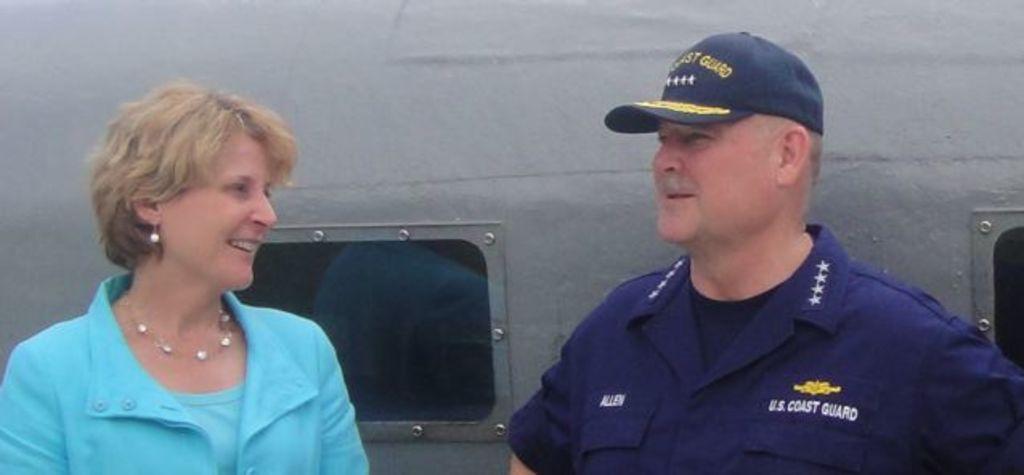What country is this coast guard member serving for?
Keep it short and to the point. U.s. 